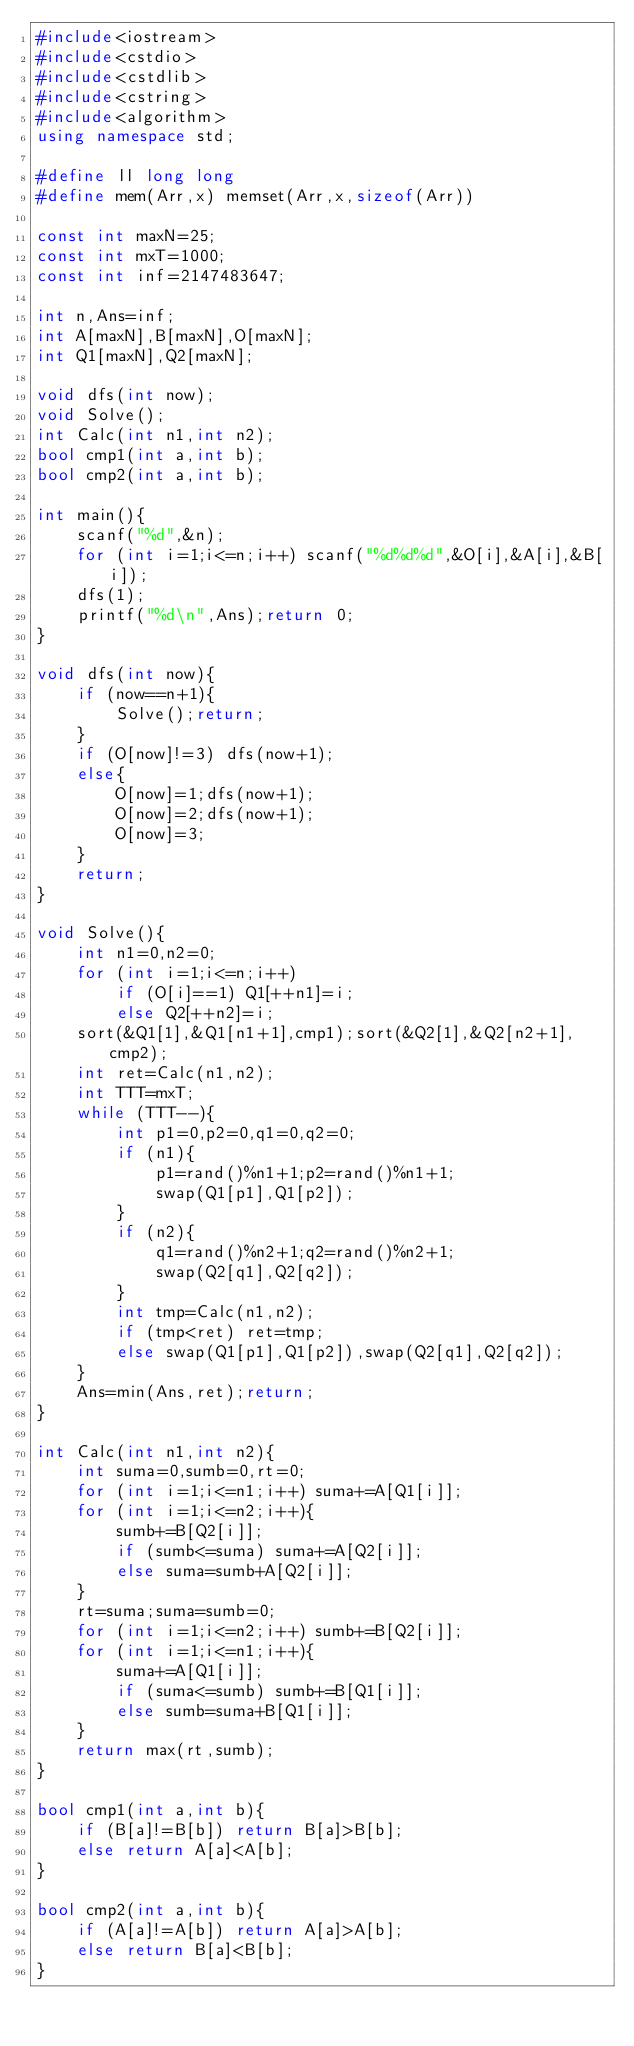Convert code to text. <code><loc_0><loc_0><loc_500><loc_500><_C++_>#include<iostream>
#include<cstdio>
#include<cstdlib>
#include<cstring>
#include<algorithm>
using namespace std;

#define ll long long
#define mem(Arr,x) memset(Arr,x,sizeof(Arr))

const int maxN=25;
const int mxT=1000;
const int inf=2147483647;

int n,Ans=inf;
int A[maxN],B[maxN],O[maxN];
int Q1[maxN],Q2[maxN];

void dfs(int now);
void Solve();
int Calc(int n1,int n2);
bool cmp1(int a,int b);
bool cmp2(int a,int b);

int main(){
	scanf("%d",&n);
	for (int i=1;i<=n;i++) scanf("%d%d%d",&O[i],&A[i],&B[i]);
	dfs(1);
	printf("%d\n",Ans);return 0;
}

void dfs(int now){
	if (now==n+1){
		Solve();return;
	}
	if (O[now]!=3) dfs(now+1);
	else{
		O[now]=1;dfs(now+1);
		O[now]=2;dfs(now+1);
		O[now]=3;
	}
	return;
}

void Solve(){
	int n1=0,n2=0;
	for (int i=1;i<=n;i++)
		if (O[i]==1) Q1[++n1]=i;
		else Q2[++n2]=i;
	sort(&Q1[1],&Q1[n1+1],cmp1);sort(&Q2[1],&Q2[n2+1],cmp2);
	int ret=Calc(n1,n2);
	int TTT=mxT;
	while (TTT--){
		int p1=0,p2=0,q1=0,q2=0;
		if (n1){
			p1=rand()%n1+1;p2=rand()%n1+1;
			swap(Q1[p1],Q1[p2]);
		}
		if (n2){
			q1=rand()%n2+1;q2=rand()%n2+1;
			swap(Q2[q1],Q2[q2]);
		}
		int tmp=Calc(n1,n2);
		if (tmp<ret) ret=tmp;
		else swap(Q1[p1],Q1[p2]),swap(Q2[q1],Q2[q2]);
	}
	Ans=min(Ans,ret);return;
}

int Calc(int n1,int n2){
	int suma=0,sumb=0,rt=0;
	for (int i=1;i<=n1;i++) suma+=A[Q1[i]];
	for (int i=1;i<=n2;i++){
		sumb+=B[Q2[i]];
		if (sumb<=suma) suma+=A[Q2[i]];
		else suma=sumb+A[Q2[i]];
	}
	rt=suma;suma=sumb=0;
	for (int i=1;i<=n2;i++) sumb+=B[Q2[i]];
	for (int i=1;i<=n1;i++){
		suma+=A[Q1[i]];
		if (suma<=sumb) sumb+=B[Q1[i]];
		else sumb=suma+B[Q1[i]];
	}
	return max(rt,sumb);
}

bool cmp1(int a,int b){
	if (B[a]!=B[b]) return B[a]>B[b];
	else return A[a]<A[b];
}

bool cmp2(int a,int b){
	if (A[a]!=A[b]) return A[a]>A[b];
	else return B[a]<B[b];
}
</code> 